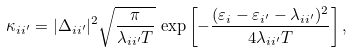Convert formula to latex. <formula><loc_0><loc_0><loc_500><loc_500>\kappa _ { i i ^ { \prime } } = | \Delta _ { i i ^ { \prime } } | ^ { 2 } \sqrt { \frac { \pi } { \lambda _ { i i ^ { \prime } } T } } \, \exp \left [ - \frac { ( \varepsilon _ { i } - \varepsilon _ { i ^ { \prime } } - \lambda _ { i i ^ { \prime } } ) ^ { 2 } } { 4 \lambda _ { i i ^ { \prime } } T } \right ] ,</formula> 